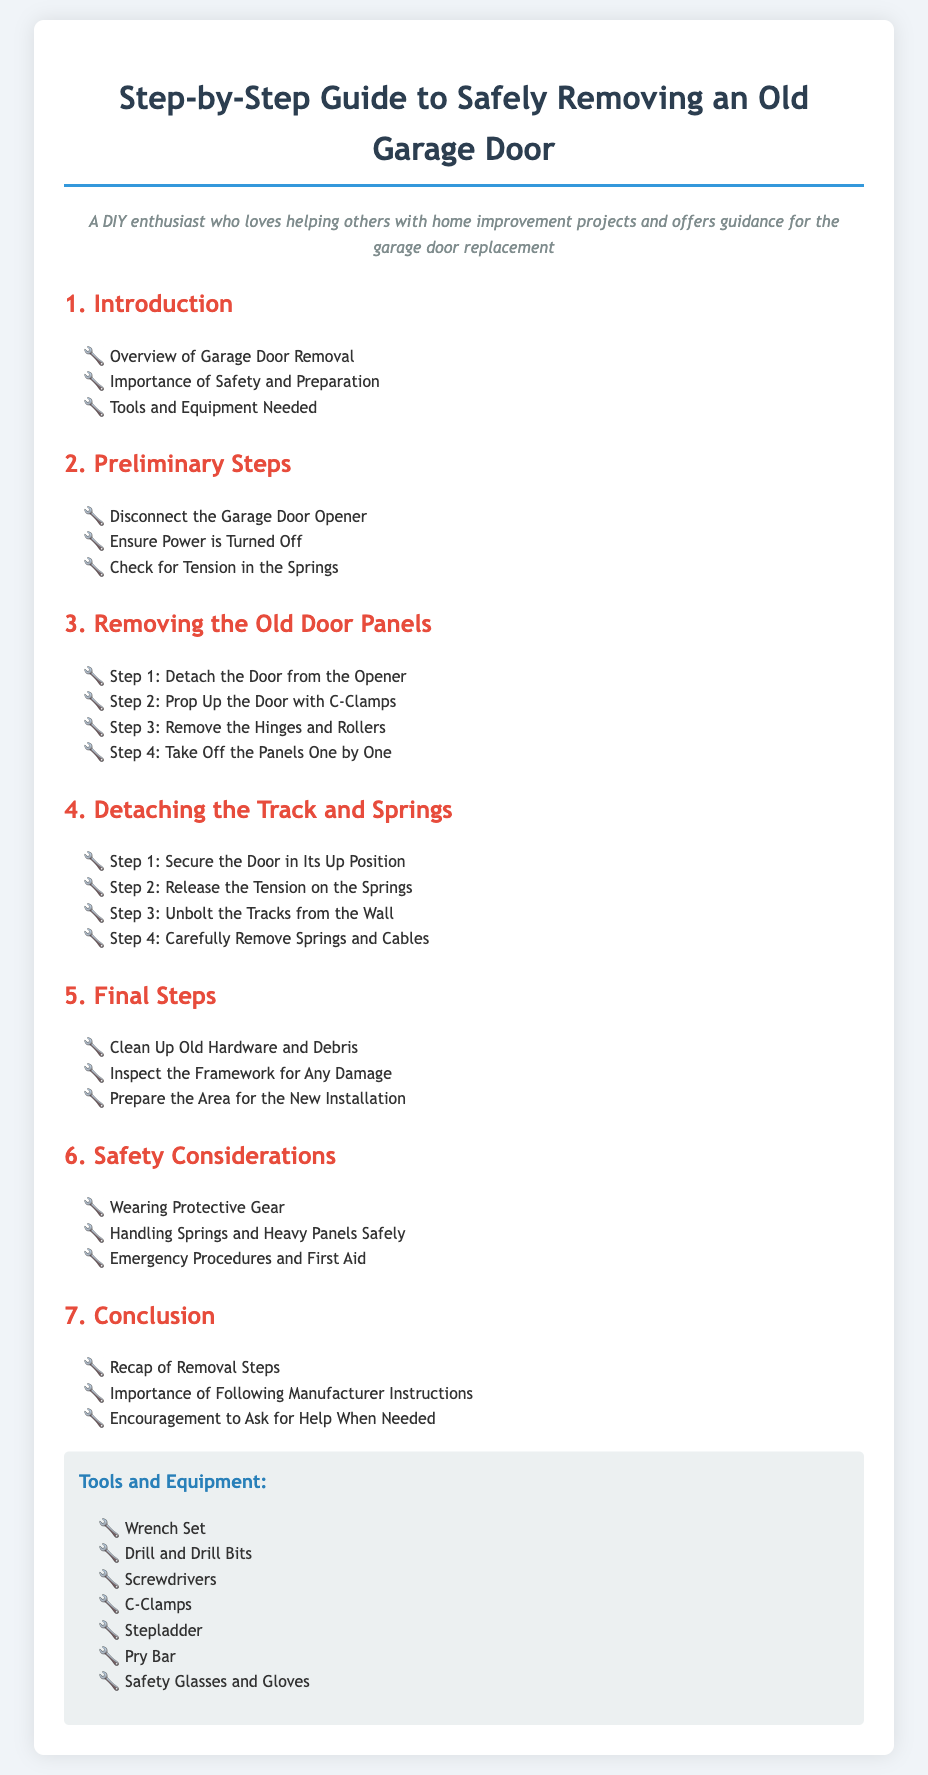What is the first step in removing an old garage door? The first step in removing an old garage door involves detaching the door from the opener.
Answer: Detach the Door from the Opener What type of gear should be worn for safety? The document mentions the importance of wearing protective gear while performing the removal.
Answer: Protective Gear How many steps are involved in the section for removing the old door panels? The old door panels section outlines four steps for removal.
Answer: Four Steps What tool is suggested to secure the door in its up position? To secure the door in its up position, C-clamps are recommended.
Answer: C-Clamps What should be inspected after the removal process? After removal, the framework should be inspected for any damage.
Answer: Framework for Any Damage How many total sections are in the guide? The guide consists of seven sections including the introduction and conclusion.
Answer: Seven Sections What is the purpose of releasing tension on the springs? Releasing tension on the springs is a necessary step before detaching the track and springs.
Answer: Detaching the Track and Springs What tool is recommended for cleaning up old hardware? The guide does not specify a tool for cleaning, but implies a general cleanup is necessary.
Answer: Cleanup (general) What should be done if help is needed during the process? The document encourages asking for help when needed during the garage door removal.
Answer: Ask for Help 